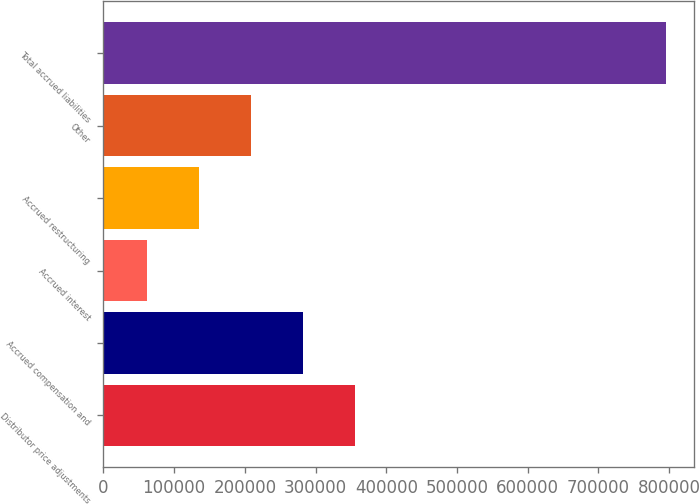Convert chart to OTSL. <chart><loc_0><loc_0><loc_500><loc_500><bar_chart><fcel>Distributor price adjustments<fcel>Accrued compensation and<fcel>Accrued interest<fcel>Accrued restructuring<fcel>Other<fcel>Total accrued liabilities<nl><fcel>355079<fcel>281623<fcel>61255<fcel>134711<fcel>208167<fcel>795816<nl></chart> 